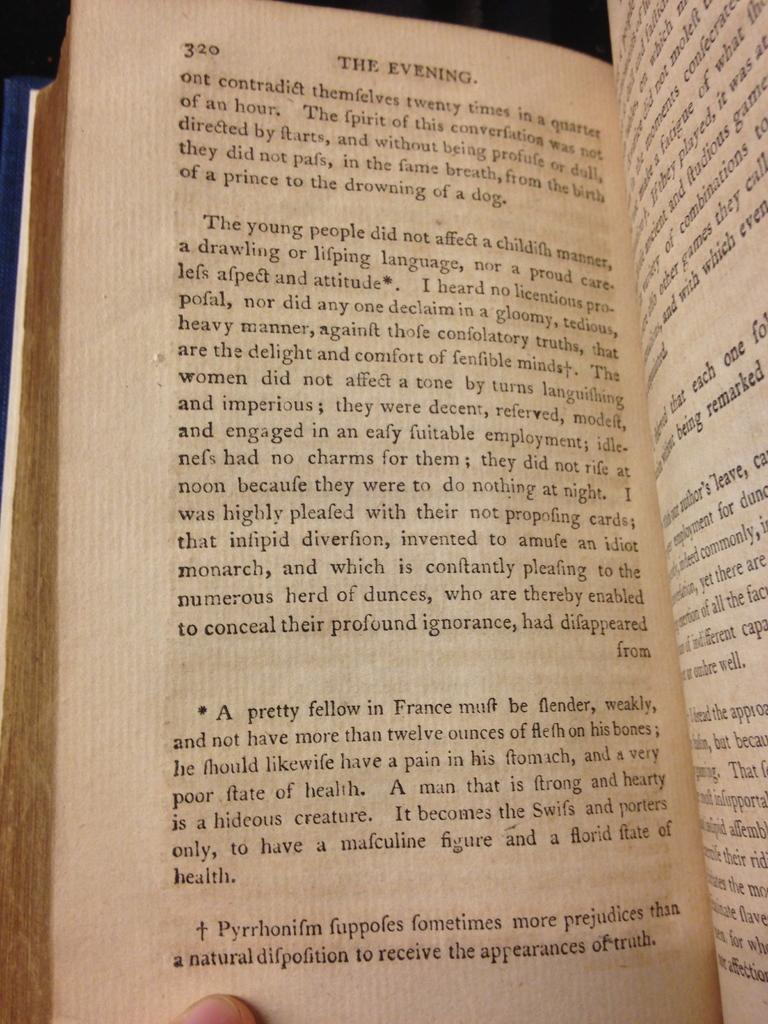<image>
Give a short and clear explanation of the subsequent image. A book is open to a chapter called The  Evening. 